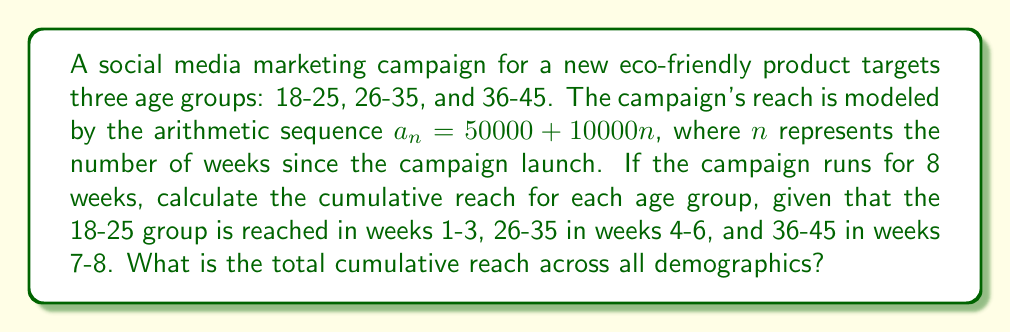Show me your answer to this math problem. To solve this problem, we need to calculate the partial sums of the arithmetic sequence for each age group and then sum them up. Let's break it down step-by-step:

1. The arithmetic sequence is given by $a_n = 50000 + 10000n$

2. For the 18-25 age group (weeks 1-3):
   $S_3 = \frac{3}{2}[2a_1 + (3-1)d]$
   $S_3 = \frac{3}{2}[2(60000) + 2(10000)] = \frac{3}{2}(140000) = 210000$

3. For the 26-35 age group (weeks 4-6):
   $S_6 - S_3 = \frac{3}{2}[2a_4 + (3-1)d]$
   $S_6 - S_3 = \frac{3}{2}[2(90000) + 2(10000)] = \frac{3}{2}(200000) = 300000$

4. For the 36-45 age group (weeks 7-8):
   $S_8 - S_6 = \frac{2}{2}[2a_7 + (2-1)d]$
   $S_8 - S_6 = \frac{2}{2}[2(120000) + 10000] = 250000$

5. Total cumulative reach:
   $210000 + 300000 + 250000 = 760000$
Answer: 760,000 